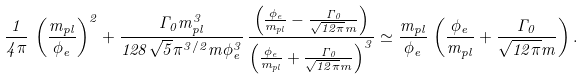<formula> <loc_0><loc_0><loc_500><loc_500>\frac { 1 } { 4 \pi } \, \left ( \frac { m _ { p l } } { \phi _ { e } } \right ) ^ { 2 } + \frac { \Gamma _ { 0 } m _ { p l } ^ { 3 } } { 1 2 8 \sqrt { 5 } \pi ^ { 3 / 2 } m \phi _ { e } ^ { 3 } } \, \frac { \left ( \frac { \phi _ { e } } { m _ { p l } } - \frac { \Gamma _ { 0 } } { \sqrt { 1 2 \pi } m } \right ) } { \left ( \frac { \phi _ { e } } { m _ { p l } } + \frac { \Gamma _ { 0 } } { \sqrt { 1 2 \pi } m } \right ) ^ { 3 } } \simeq \frac { m _ { p l } } { \phi _ { e } } \, \left ( \frac { \phi _ { e } } { m _ { p l } } + \frac { \Gamma _ { 0 } } { \sqrt { 1 2 \pi } m } \right ) .</formula> 